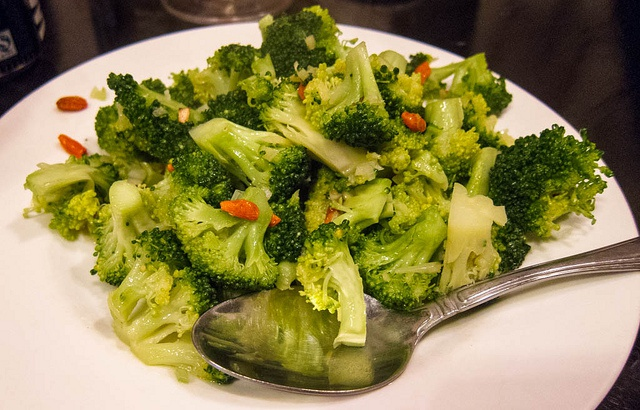Describe the objects in this image and their specific colors. I can see broccoli in black, olive, and khaki tones and spoon in black, olive, and gray tones in this image. 